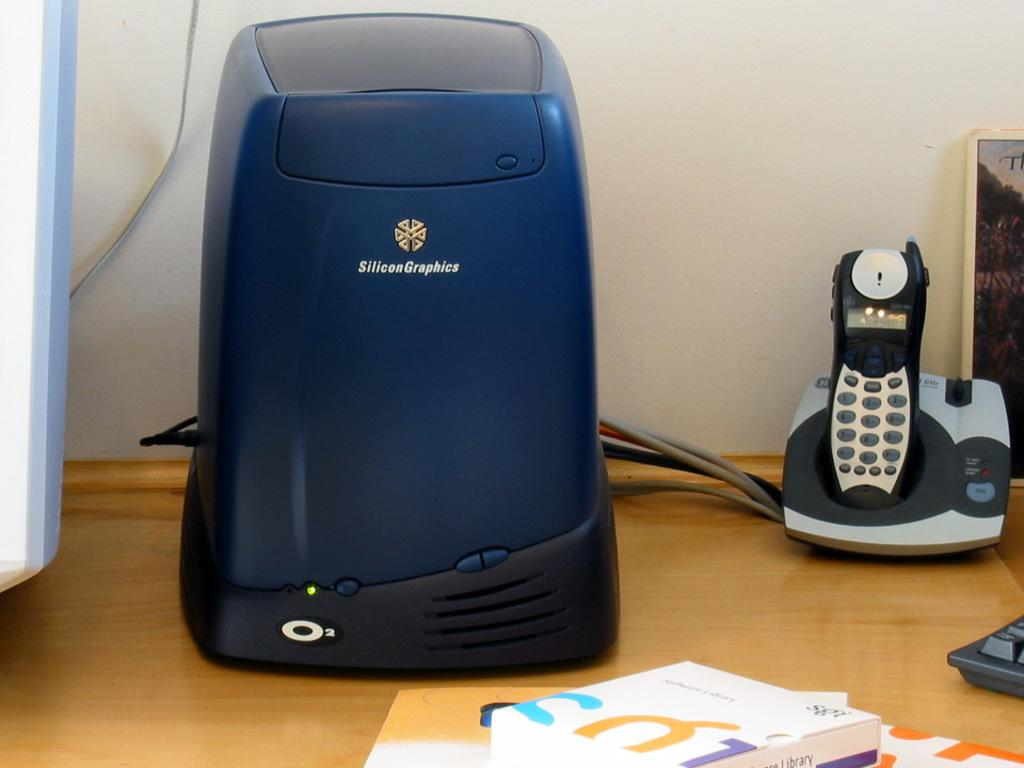<image>
Summarize the visual content of the image. an electronics item with Silicon Graphics on it. 